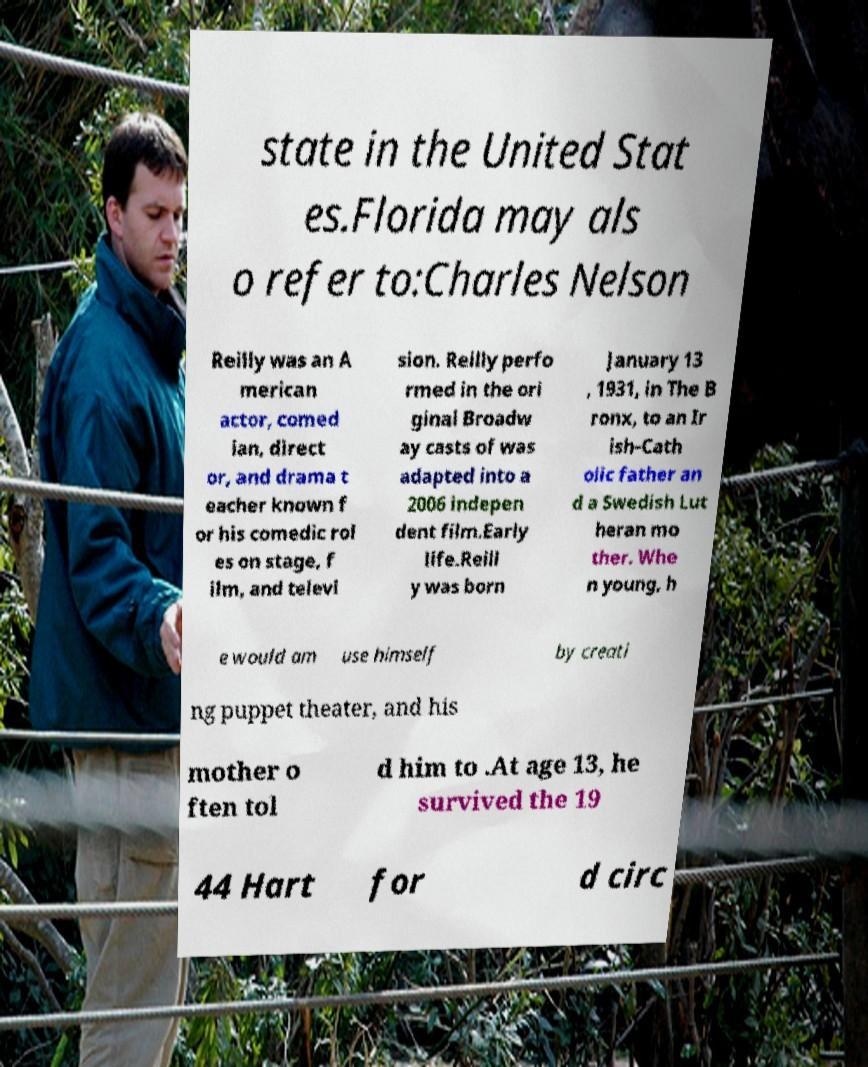There's text embedded in this image that I need extracted. Can you transcribe it verbatim? state in the United Stat es.Florida may als o refer to:Charles Nelson Reilly was an A merican actor, comed ian, direct or, and drama t eacher known f or his comedic rol es on stage, f ilm, and televi sion. Reilly perfo rmed in the ori ginal Broadw ay casts of was adapted into a 2006 indepen dent film.Early life.Reill y was born January 13 , 1931, in The B ronx, to an Ir ish-Cath olic father an d a Swedish Lut heran mo ther. Whe n young, h e would am use himself by creati ng puppet theater, and his mother o ften tol d him to .At age 13, he survived the 19 44 Hart for d circ 